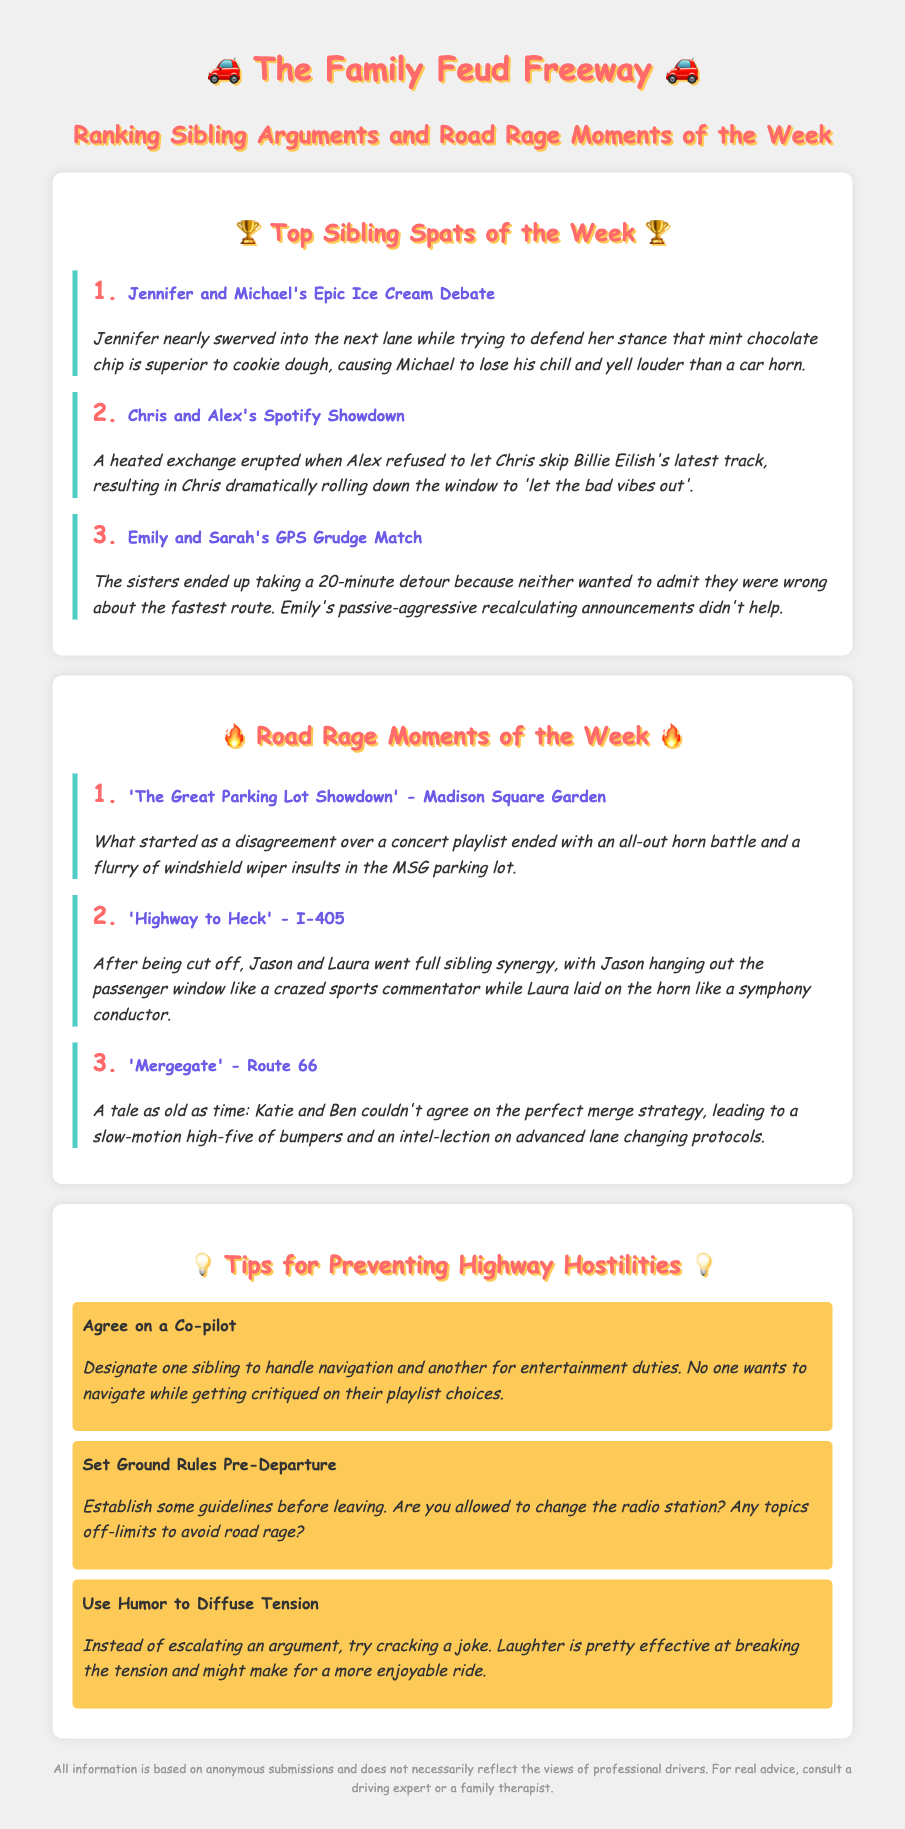What is the top sibling spat of the week? The top sibling spat is ranked by the intensity of the arguments, with "Jennifer and Michael's Epic Ice Cream Debate" taking the first place.
Answer: Jennifer and Michael's Epic Ice Cream Debate Who had a showdown over Spotify? Information about sibling arguments is included in the document, specifically mentioning "Chris and Alex" arguing over music.
Answer: Chris and Alex What was the detour time taken by Emily and Sarah? The document states a specific duration for their detour based on their GPS disagreement.
Answer: 20 minutes What location did 'The Great Parking Lot Showdown' occur? The document specifies a location where one of the road rage moments took place, namely a well-known venue in New York.
Answer: Madison Square Garden How did Jason and Laura react after being cut off? Combining their actions in response to road rage illustrates their sibling synergy, which involved dramatic gestures and noises.
Answer: Crazed sports commentator What advice is given to prevent sibling arguments in the car? The document provides a tip specifically aimed at improving sibling interactions during car rides.
Answer: Agree on a Co-pilot What is a suggested method to diffuse tension? A tip in the document emphasizes the use of humor as a strategy in avoiding escalation during sibling disputes.
Answer: Use Humor to Diffuse Tension What is the ranking of 'Mergegate'? This question requires determining its position among the listed road rage moments based on the document's details.
Answer: 3 Who ended up with a high-five of bumpers? The document describes a situation involving two siblings and their merging problems leading to physical contact.
Answer: Katie and Ben 